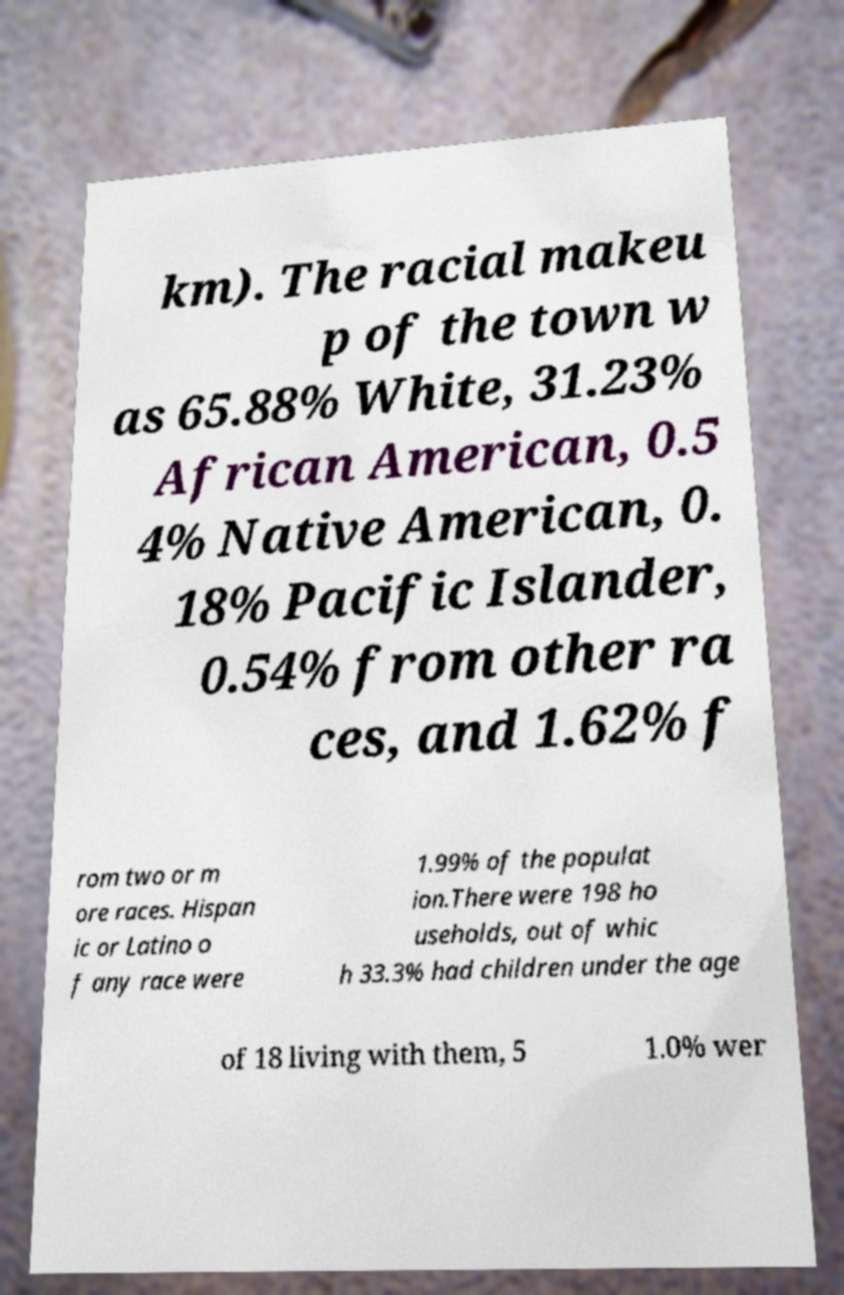Can you read and provide the text displayed in the image?This photo seems to have some interesting text. Can you extract and type it out for me? km). The racial makeu p of the town w as 65.88% White, 31.23% African American, 0.5 4% Native American, 0. 18% Pacific Islander, 0.54% from other ra ces, and 1.62% f rom two or m ore races. Hispan ic or Latino o f any race were 1.99% of the populat ion.There were 198 ho useholds, out of whic h 33.3% had children under the age of 18 living with them, 5 1.0% wer 